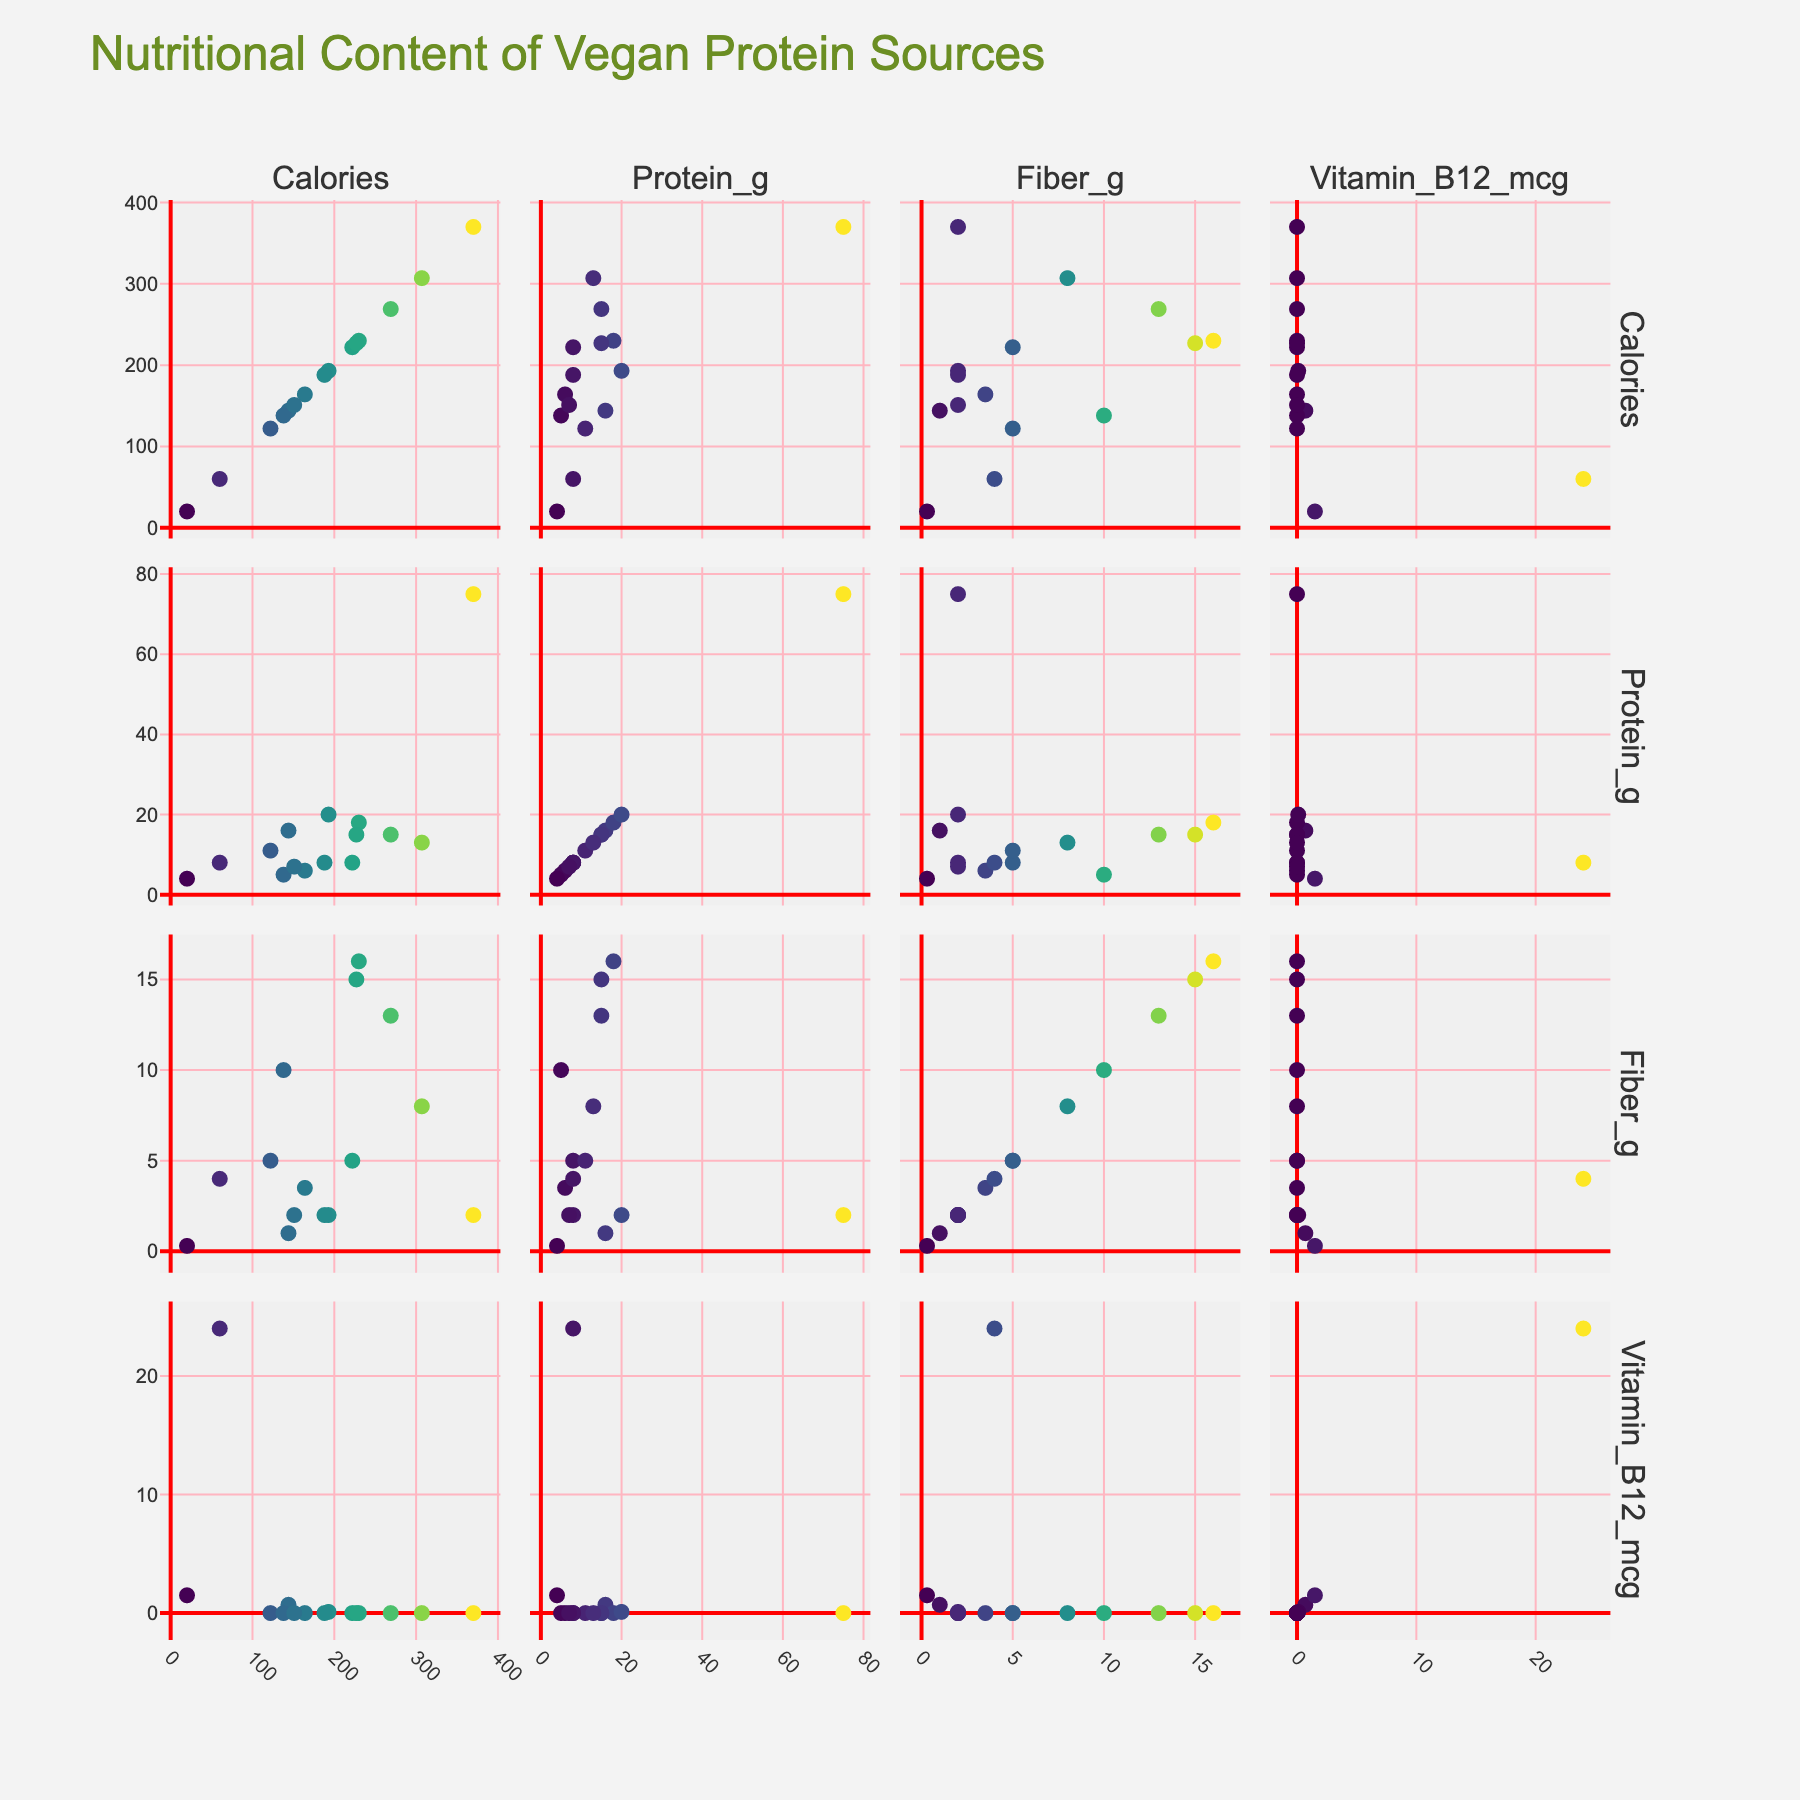What is the title of the figure? The title is typically shown at the top of the figure. The text "Nutritional Content of Vegan Protein Sources" appears as the title.
Answer: Nutritional Content of Vegan Protein Sources What are the axis labels for the scatter plot in the first row and first column? The axis labels in the scatter plot matrix correspond to the nutritional metrics being compared. The first row and first column compare "Calories" to "Calories".
Answer: Calories vs Calories Which vegan protein source has the highest value for Vitamin B12? By looking at the scatter plot where the y-axis is 'Vitamin B12_mcg', it is noticeable the point at the highest value is associated with Nutritional Yeast. Hovering over the data points confirms Nutritional Yeast.
Answer: Nutritional Yeast Which protein source has the most fiber? By checking the scatter plot where 'Fiber_g' is on the y-axis, the highest data point corresponds to Lentils.
Answer: Lentils How many points are in each scatter plot? Since the same protein sources are plotted in each scatter plot matrix, we can count from one plot and verify across others too. There are 14 data points, each corresponding to a protein source.
Answer: 14 Which protein source has the highest amount of protein? By examining the scatter plot comparing 'Protein_g' on the y-axis, Seitan stands out as having the highest amount of protein.
Answer: Seitan What is the average fiber content for foods with more than 15g of protein? First, identify the sources with >15g protein: Lentils, Tempeh, Seitan. Then locate their fiber contents (16, 2, 2). Average: (16 + 2 + 2) / 3 = 6.67
Answer: 6.67 Which two protein sources have the closest calorie content, and what is the difference? Observing the scatter plot where 'Calories' is plotted, Edamame and Pumpkin Seeds appear closest. Pumpkin Seeds at 151 and Edamame at 122. Difference: 151 - 122 = 29
Answer: Edamame and Pumpkin Seeds, 29 Is there a relation between calories and the amount of protein? To determine this, examine the scatter plot of 'Calories' vs 'Protein_g'. The data points show no clear linear relationship; protein content does not consistently increase/decrease with calories.
Answer: No clear relation In the scatter plot comparing fiber content and vitamin B12, which protein source is isolated in the top-right corner? In the scatter plot of 'Vitamin_B12_mcg' vs 'Fiber_g', the highest point on the Vitamin B12 axis with significant fiber is Nutritional Yeast.
Answer: Nutritional Yeast 